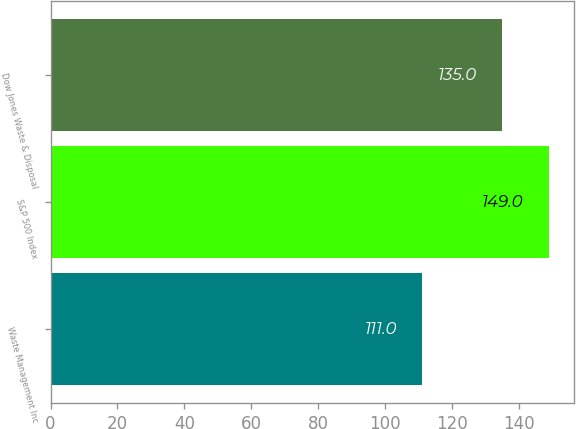Convert chart. <chart><loc_0><loc_0><loc_500><loc_500><bar_chart><fcel>Waste Management Inc<fcel>S&P 500 Index<fcel>Dow Jones Waste & Disposal<nl><fcel>111<fcel>149<fcel>135<nl></chart> 